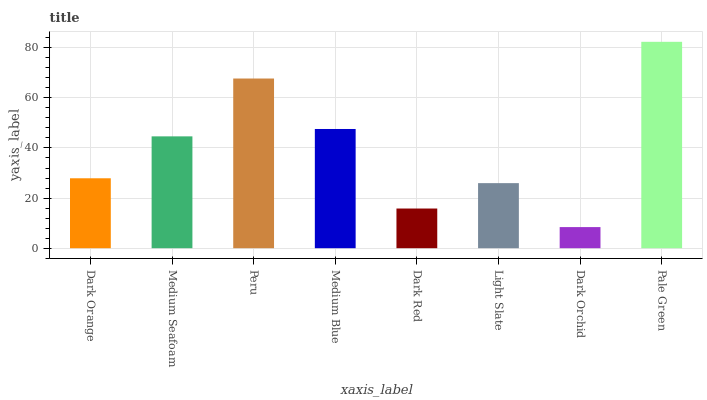Is Dark Orchid the minimum?
Answer yes or no. Yes. Is Pale Green the maximum?
Answer yes or no. Yes. Is Medium Seafoam the minimum?
Answer yes or no. No. Is Medium Seafoam the maximum?
Answer yes or no. No. Is Medium Seafoam greater than Dark Orange?
Answer yes or no. Yes. Is Dark Orange less than Medium Seafoam?
Answer yes or no. Yes. Is Dark Orange greater than Medium Seafoam?
Answer yes or no. No. Is Medium Seafoam less than Dark Orange?
Answer yes or no. No. Is Medium Seafoam the high median?
Answer yes or no. Yes. Is Dark Orange the low median?
Answer yes or no. Yes. Is Medium Blue the high median?
Answer yes or no. No. Is Dark Orchid the low median?
Answer yes or no. No. 